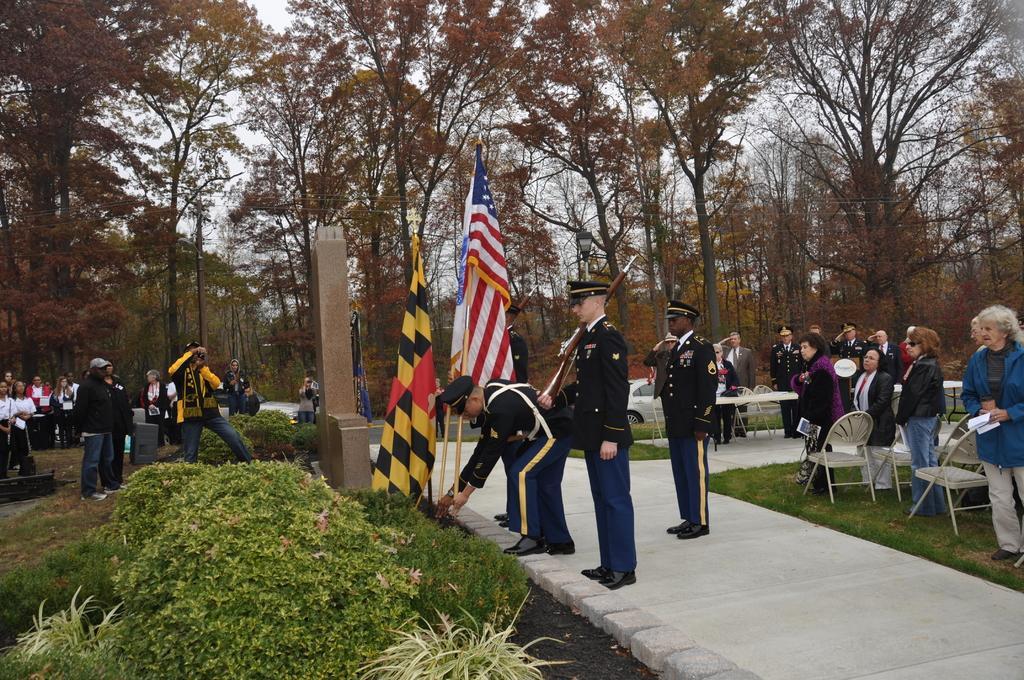Please provide a concise description of this image. In this image, there are people standing on grassland and few are standing on a path and there are flags, plants in the background there are trees, near the people there are chairs and tables. 